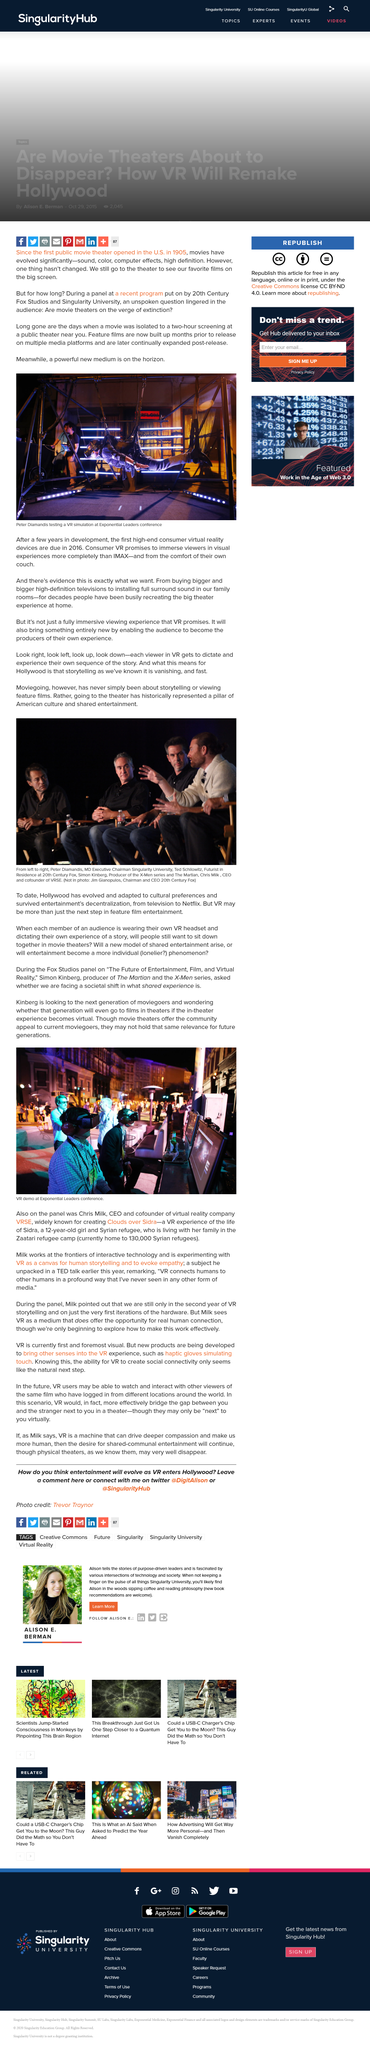Identify some key points in this picture. The storytelling aspect of Hollywood is disappearing rapidly due to the emergence of VR technology. The person in the photo at the Exponential Leaders conference is testing a VR simulation, and their name is Peter Diamandis. The picture depicts a virtual reality (VR) demonstration at the Exponential Leaders conference. The first public movie theater was opened in the United States in 1905, marking a significant milestone in the history of cinema. Simon Kinberg produced both The Martian and the X-men series. 